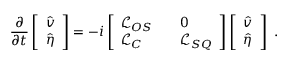Convert formula to latex. <formula><loc_0><loc_0><loc_500><loc_500>\frac { \partial } { \partial t } \left [ \begin{array} { l } { \hat { v } } \\ { \hat { \eta } } \end{array} \right ] = - i \left [ \begin{array} { l l l } { \mathcal { L } _ { O S } } & { 0 } \\ { \mathcal { L } _ { C } } & { \mathcal { L } _ { S Q } } \end{array} \right ] \left [ \begin{array} { l } { \hat { v } } \\ { \hat { \eta } } \end{array} \right ] .</formula> 